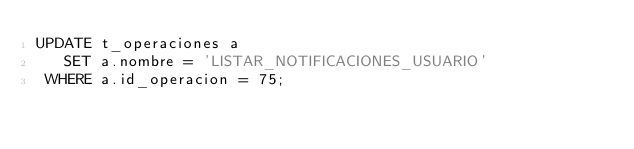Convert code to text. <code><loc_0><loc_0><loc_500><loc_500><_SQL_>UPDATE t_operaciones a
   SET a.nombre = 'LISTAR_NOTIFICACIONES_USUARIO'
 WHERE a.id_operacion = 75;
</code> 